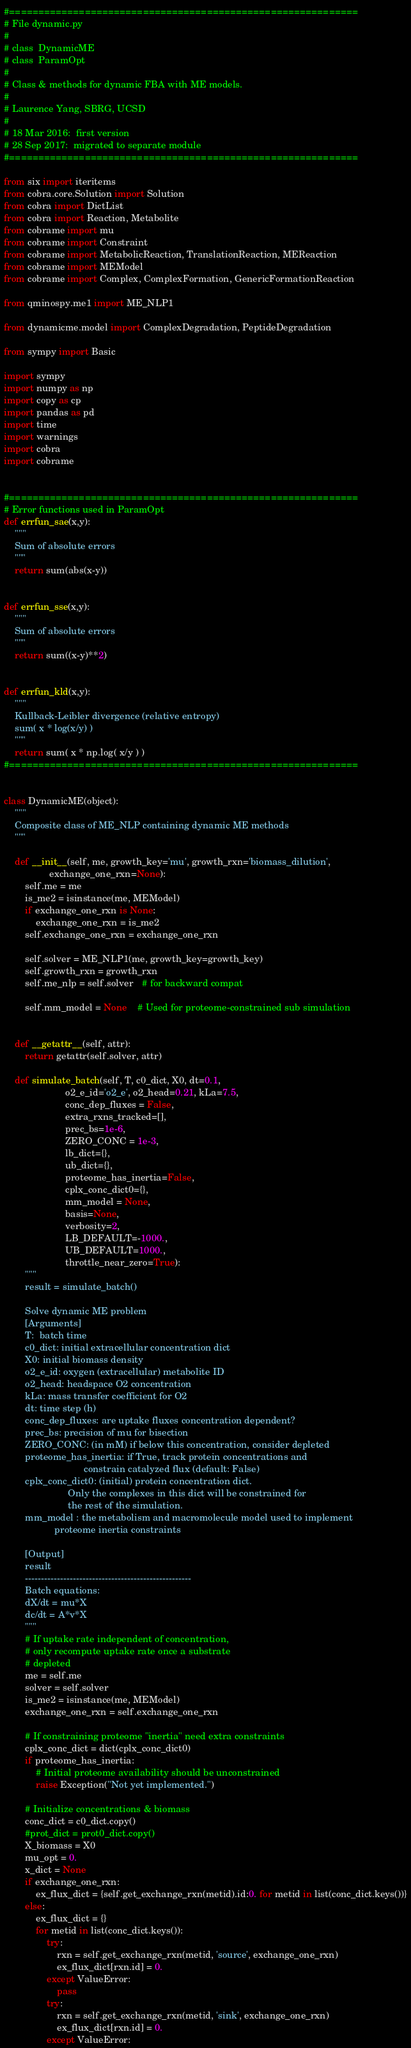Convert code to text. <code><loc_0><loc_0><loc_500><loc_500><_Python_>#============================================================
# File dynamic.py
#
# class  DynamicME
# class  ParamOpt
#
# Class & methods for dynamic FBA with ME models.
#
# Laurence Yang, SBRG, UCSD
#
# 18 Mar 2016:  first version
# 28 Sep 2017:  migrated to separate module
#============================================================

from six import iteritems
from cobra.core.Solution import Solution
from cobra import DictList
from cobra import Reaction, Metabolite
from cobrame import mu
from cobrame import Constraint
from cobrame import MetabolicReaction, TranslationReaction, MEReaction
from cobrame import MEModel
from cobrame import Complex, ComplexFormation, GenericFormationReaction

from qminospy.me1 import ME_NLP1

from dynamicme.model import ComplexDegradation, PeptideDegradation

from sympy import Basic

import sympy
import numpy as np
import copy as cp
import pandas as pd
import time
import warnings
import cobra
import cobrame


#============================================================
# Error functions used in ParamOpt
def errfun_sae(x,y):
    """
    Sum of absolute errors
    """
    return sum(abs(x-y))


def errfun_sse(x,y):
    """
    Sum of absolute errors
    """
    return sum((x-y)**2)


def errfun_kld(x,y):
    """
    Kullback-Leibler divergence (relative entropy)
    sum( x * log(x/y) )
    """
    return sum( x * np.log( x/y ) )
#============================================================


class DynamicME(object):
    """
    Composite class of ME_NLP containing dynamic ME methods
    """

    def __init__(self, me, growth_key='mu', growth_rxn='biomass_dilution',
                 exchange_one_rxn=None):
        self.me = me
        is_me2 = isinstance(me, MEModel)
        if exchange_one_rxn is None:
            exchange_one_rxn = is_me2
        self.exchange_one_rxn = exchange_one_rxn

        self.solver = ME_NLP1(me, growth_key=growth_key)
        self.growth_rxn = growth_rxn
        self.me_nlp = self.solver   # for backward compat

        self.mm_model = None    # Used for proteome-constrained sub simulation


    def __getattr__(self, attr):
        return getattr(self.solver, attr)

    def simulate_batch(self, T, c0_dict, X0, dt=0.1,
                       o2_e_id='o2_e', o2_head=0.21, kLa=7.5,
                       conc_dep_fluxes = False,
                       extra_rxns_tracked=[],
                       prec_bs=1e-6,
                       ZERO_CONC = 1e-3,
                       lb_dict={},
                       ub_dict={},
                       proteome_has_inertia=False,
                       cplx_conc_dict0={},
                       mm_model = None,
                       basis=None,
                       verbosity=2,
                       LB_DEFAULT=-1000.,
                       UB_DEFAULT=1000.,
                       throttle_near_zero=True):
        """
        result = simulate_batch()

        Solve dynamic ME problem
        [Arguments]
        T:  batch time
        c0_dict: initial extracellular concentration dict
        X0: initial biomass density
        o2_e_id: oxygen (extracellular) metabolite ID
        o2_head: headspace O2 concentration
        kLa: mass transfer coefficient for O2
        dt: time step (h)
        conc_dep_fluxes: are uptake fluxes concentration dependent?
        prec_bs: precision of mu for bisection
        ZERO_CONC: (in mM) if below this concentration, consider depleted
        proteome_has_inertia: if True, track protein concentrations and
                              constrain catalyzed flux (default: False)
        cplx_conc_dict0: (initial) protein concentration dict.
                        Only the complexes in this dict will be constrained for
                        the rest of the simulation.
        mm_model : the metabolism and macromolecule model used to implement
                   proteome inertia constraints

        [Output]
        result
        ----------------------------------------------------
        Batch equations:
        dX/dt = mu*X
        dc/dt = A*v*X
        """
        # If uptake rate independent of concentration,
        # only recompute uptake rate once a substrate
        # depleted
        me = self.me
        solver = self.solver
        is_me2 = isinstance(me, MEModel)
        exchange_one_rxn = self.exchange_one_rxn

        # If constraining proteome "inertia" need extra constraints
        cplx_conc_dict = dict(cplx_conc_dict0)
        if proteome_has_inertia:
            # Initial proteome availability should be unconstrained
            raise Exception("Not yet implemented.")

        # Initialize concentrations & biomass
        conc_dict = c0_dict.copy()
        #prot_dict = prot0_dict.copy()
        X_biomass = X0
        mu_opt = 0.
        x_dict = None
        if exchange_one_rxn:
            ex_flux_dict = {self.get_exchange_rxn(metid).id:0. for metid in list(conc_dict.keys())}
        else:
            ex_flux_dict = {}
            for metid in list(conc_dict.keys()):
                try:
                    rxn = self.get_exchange_rxn(metid, 'source', exchange_one_rxn)
                    ex_flux_dict[rxn.id] = 0.
                except ValueError:
                    pass
                try:
                    rxn = self.get_exchange_rxn(metid, 'sink', exchange_one_rxn)
                    ex_flux_dict[rxn.id] = 0.
                except ValueError:</code> 